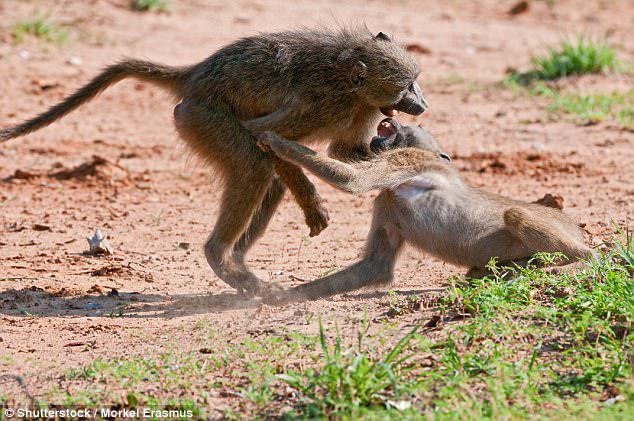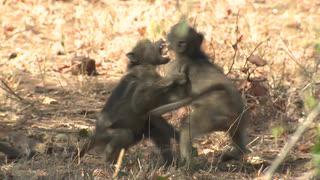The first image is the image on the left, the second image is the image on the right. For the images shown, is this caption "A baboon is carrying its young in one of the images." true? Answer yes or no. No. The first image is the image on the left, the second image is the image on the right. Evaluate the accuracy of this statement regarding the images: "In one image, two baboons are fighting, at least one with fangs bared, and the tail of the monkey on the left is extended with a bend in it.". Is it true? Answer yes or no. Yes. 